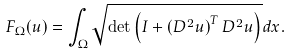<formula> <loc_0><loc_0><loc_500><loc_500>F _ { \Omega } ( u ) = \int _ { \Omega } \sqrt { \det \left ( I + \left ( D ^ { 2 } u \right ) ^ { T } D ^ { 2 } u \right ) } d x .</formula> 